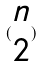Convert formula to latex. <formula><loc_0><loc_0><loc_500><loc_500>( \begin{matrix} n \\ 2 \end{matrix} )</formula> 